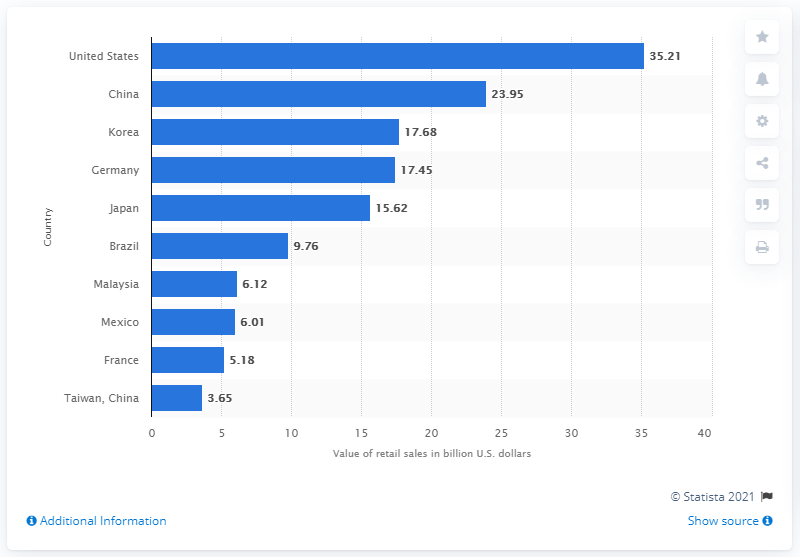Specify some key components in this picture. In 2019, the direct selling market in the United States generated retail sales of approximately 35.21 billion dollars. 